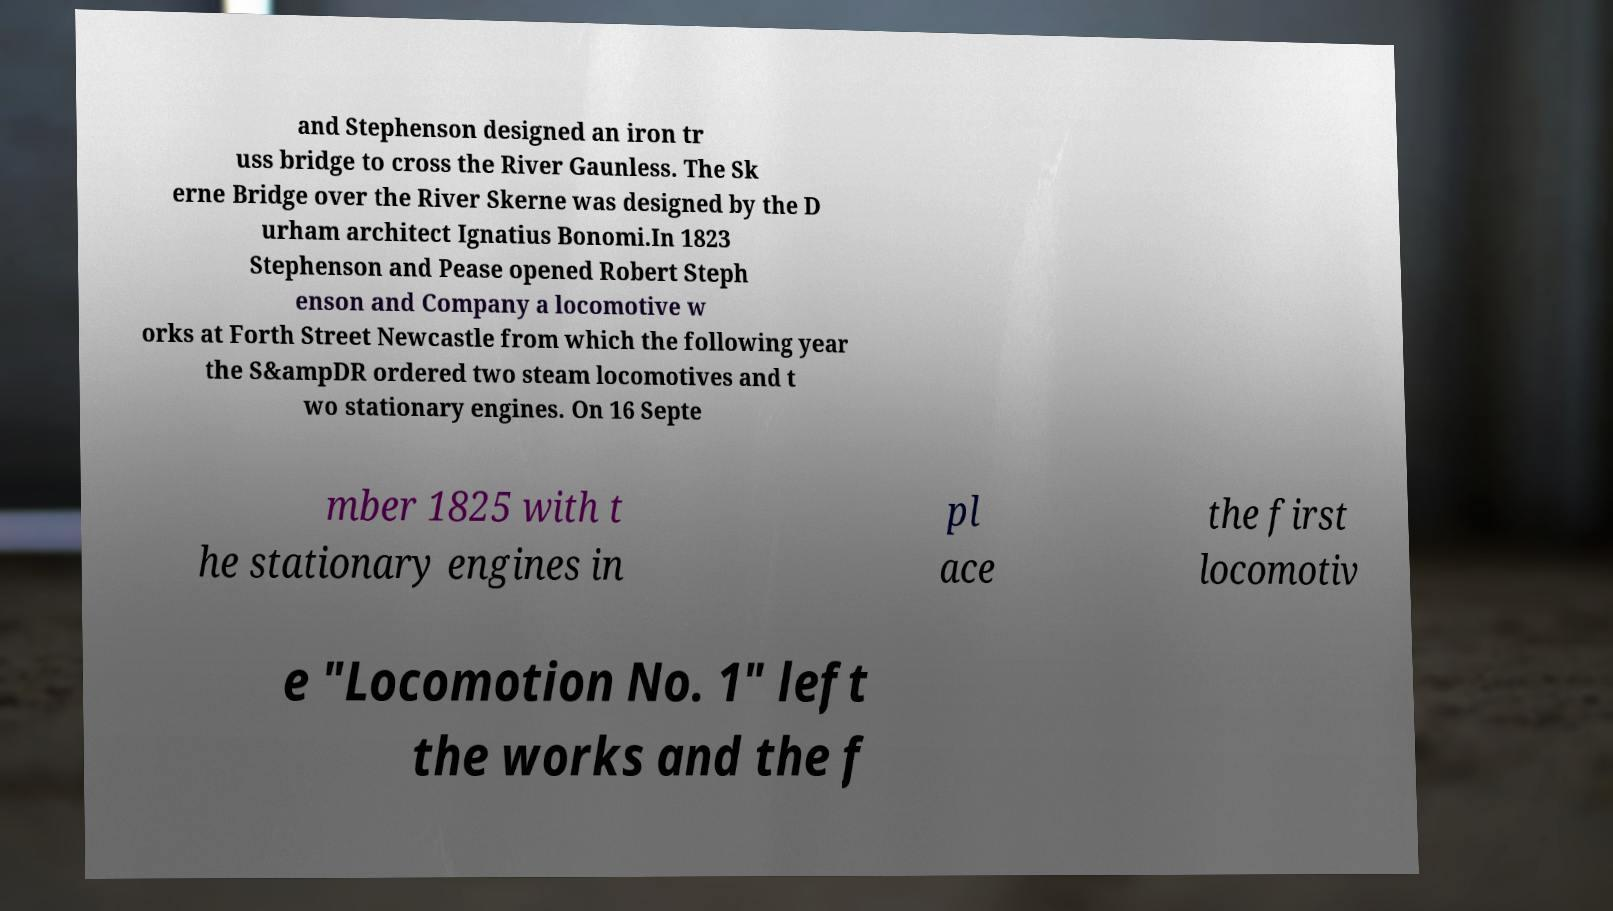What messages or text are displayed in this image? I need them in a readable, typed format. and Stephenson designed an iron tr uss bridge to cross the River Gaunless. The Sk erne Bridge over the River Skerne was designed by the D urham architect Ignatius Bonomi.In 1823 Stephenson and Pease opened Robert Steph enson and Company a locomotive w orks at Forth Street Newcastle from which the following year the S&ampDR ordered two steam locomotives and t wo stationary engines. On 16 Septe mber 1825 with t he stationary engines in pl ace the first locomotiv e "Locomotion No. 1" left the works and the f 